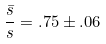Convert formula to latex. <formula><loc_0><loc_0><loc_500><loc_500>\frac { \bar { s } } { s } = . 7 5 \pm . 0 6</formula> 